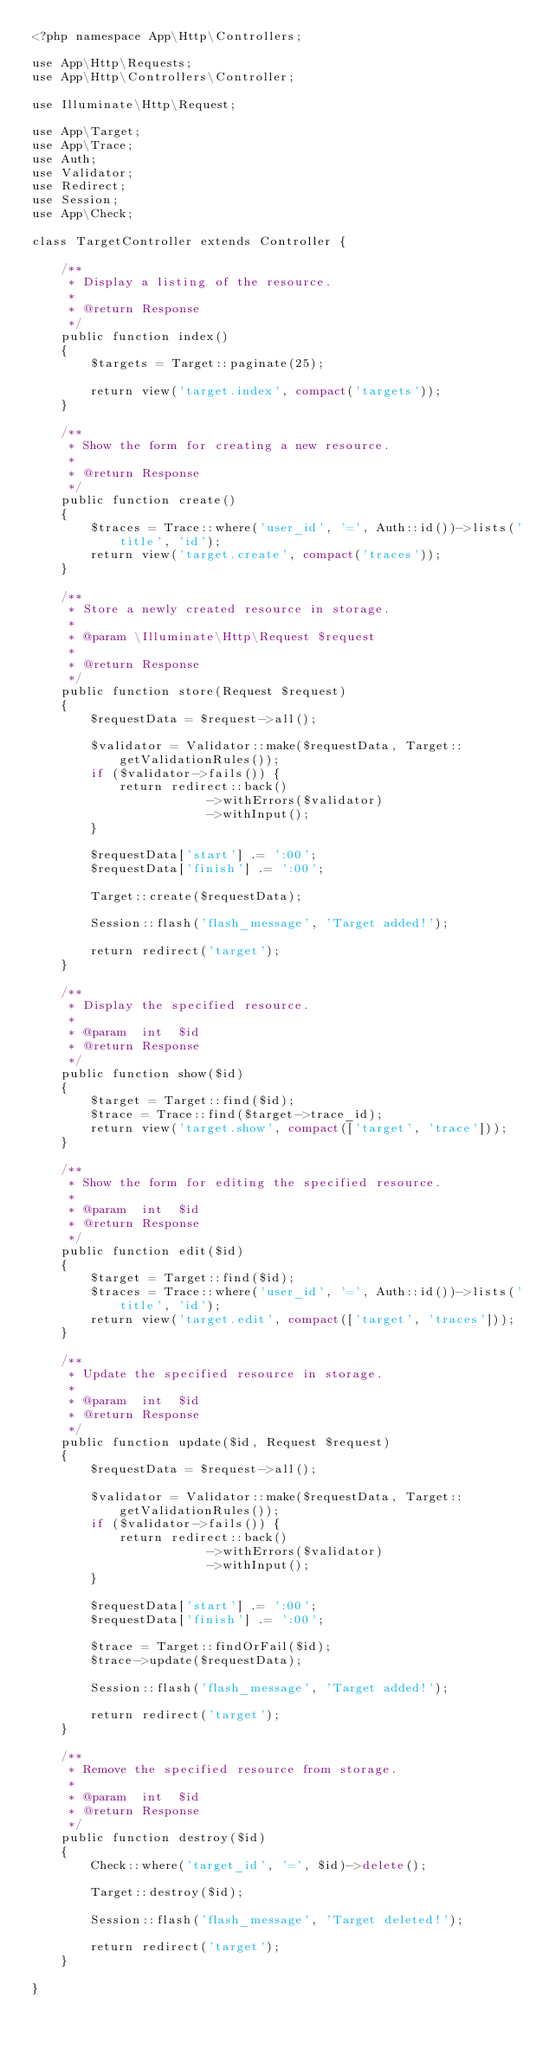Convert code to text. <code><loc_0><loc_0><loc_500><loc_500><_PHP_><?php namespace App\Http\Controllers;

use App\Http\Requests;
use App\Http\Controllers\Controller;

use Illuminate\Http\Request;

use App\Target;
use App\Trace;
use Auth;
use Validator;
use Redirect;
use Session;
use App\Check;

class TargetController extends Controller {

	/**
	 * Display a listing of the resource.
	 *
	 * @return Response
	 */
	public function index()
	{
		$targets = Target::paginate(25);

        return view('target.index', compact('targets'));
	}

	/**
	 * Show the form for creating a new resource.
	 *
	 * @return Response
	 */
	public function create()
	{
		$traces = Trace::where('user_id', '=', Auth::id())->lists('title', 'id');
		return view('target.create', compact('traces'));
	}

	/**
	 * Store a newly created resource in storage.
	 *
	 * @param \Illuminate\Http\Request $request
	 *
	 * @return Response
	 */
	public function store(Request $request)
	{
		$requestData = $request->all();

        $validator = Validator::make($requestData, Target::getValidationRules());
        if ($validator->fails()) {
            return redirect::back()
                        ->withErrors($validator)
                        ->withInput();
        }

		$requestData['start'] .= ':00';
		$requestData['finish'] .= ':00';

        Target::create($requestData);

        Session::flash('flash_message', 'Target added!');

        return redirect('target');
	}

	/**
	 * Display the specified resource.
	 *
	 * @param  int  $id
	 * @return Response
	 */
	public function show($id)
	{
		$target = Target::find($id);
		$trace = Trace::find($target->trace_id);
		return view('target.show', compact(['target', 'trace']));
	}

	/**
	 * Show the form for editing the specified resource.
	 *
	 * @param  int  $id
	 * @return Response
	 */
	public function edit($id)
	{
		$target = Target::find($id);
		$traces = Trace::where('user_id', '=', Auth::id())->lists('title', 'id');
		return view('target.edit', compact(['target', 'traces']));
	}

	/**
	 * Update the specified resource in storage.
	 *
	 * @param  int  $id
	 * @return Response
	 */
	public function update($id, Request $request)
	{
		$requestData = $request->all();

        $validator = Validator::make($requestData, Target::getValidationRules());
        if ($validator->fails()) {
            return redirect::back()
                        ->withErrors($validator)
                        ->withInput();
        }

		$requestData['start'] .= ':00';
		$requestData['finish'] .= ':00';

		$trace = Target::findOrFail($id);
        $trace->update($requestData);

        Session::flash('flash_message', 'Target added!');

        return redirect('target');
	}

	/**
	 * Remove the specified resource from storage.
	 *
	 * @param  int  $id
	 * @return Response
	 */
	public function destroy($id)
	{
		Check::where('target_id', '=', $id)->delete();
		
		Target::destroy($id);

        Session::flash('flash_message', 'Target deleted!');

        return redirect('target');
	}

}
</code> 